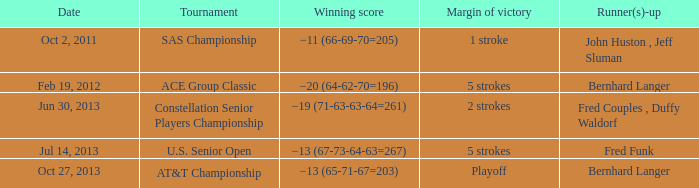Which Margin of victory has a Tournament of u.s. senior open? 5 strokes. 